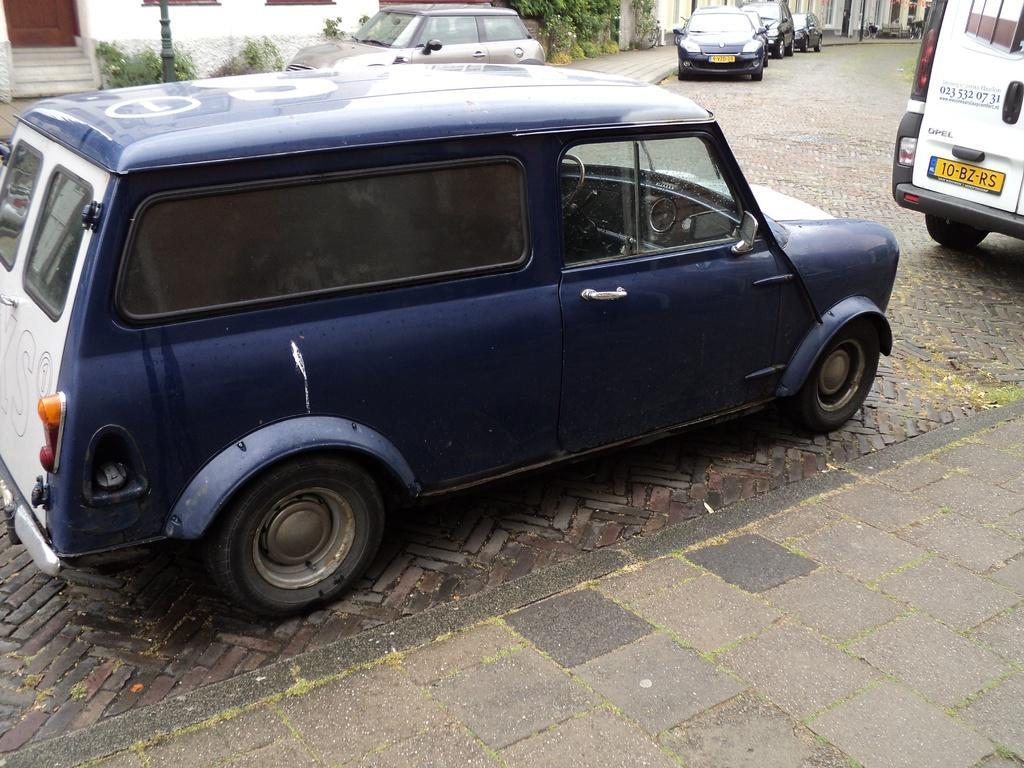Please provide a concise description of this image. In the middle of the image we can see some vehicles on the road. Behind the vehicles we can see some plants, poles and buildings. 